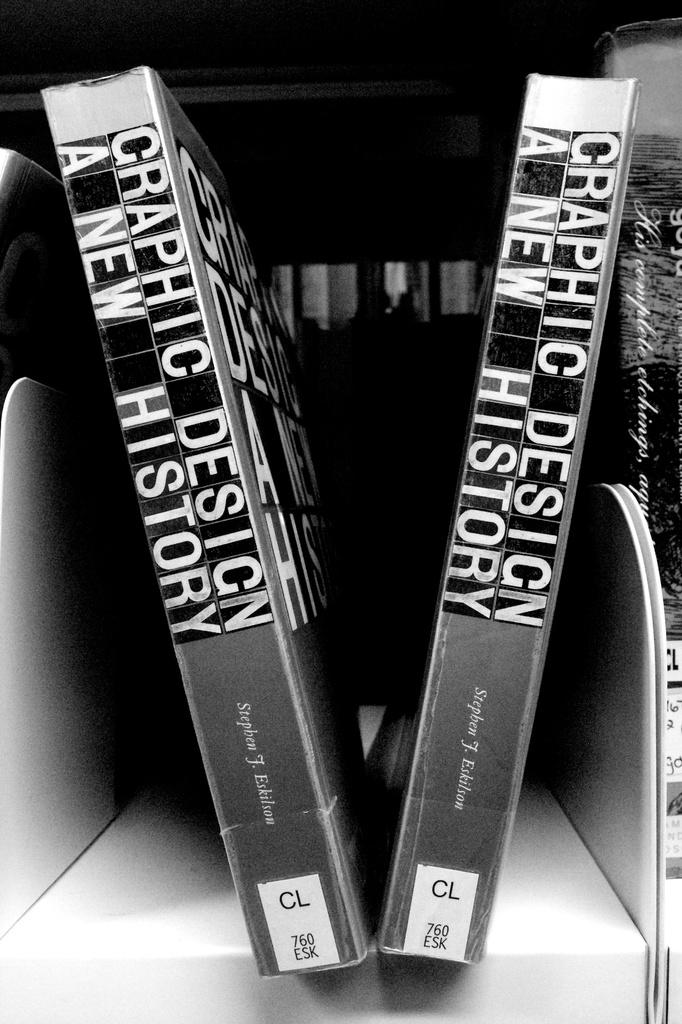<image>
Provide a brief description of the given image. Two copies of Graphic Design: A New History sit on the shelf. 